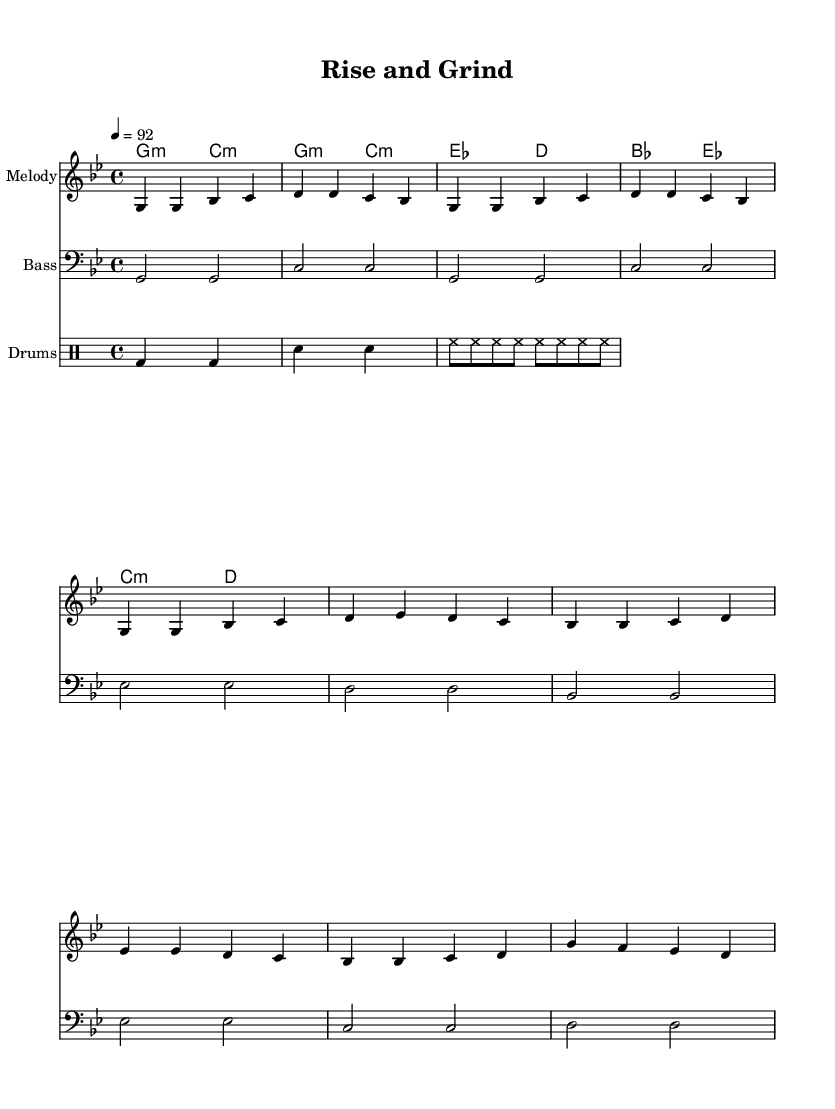What is the key signature of this music? The key signature is indicated at the beginning of the piece and shows two flats, which is the signature for G minor.
Answer: G minor What is the time signature of this music? The time signature appears at the beginning of the score, which is 4/4, meaning there are four beats in each measure.
Answer: 4/4 What is the tempo marking of the piece? The tempo marking indicates how fast the piece should be played. Here, it is marked as 4 = 92, which means that the quarter note is to be played at 92 beats per minute.
Answer: 92 How many bars are in the verse section? By counting the measures in the "Verse" part of the melody, we find there are eight bars. Therefore, the total count for the verse section is 8.
Answer: 8 What is the main theme of the lyrics in the chorus? The chorus lyrics focus on perseverance and ignoring past failures to achieve success, summarizing the overarching message of financial growth.
Answer: Perseverance What type of drum pattern is utilized in the piece? The drum section is primarily built around a standard hip-hop beat consisting of bass and snare hits with a consistent hi-hat rhythm, typical of hip-hop music styles.
Answer: Hip-hop beat What financial concept is emphasized in the lyrics? The lyrics celebrate financial growth by referencing profits and overcoming challenges, which is a clear representation of entrepreneurship and success narratives.
Answer: Financial growth 